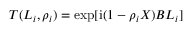<formula> <loc_0><loc_0><loc_500><loc_500>T ( L _ { i } , \rho _ { i } ) = \exp [ i ( 1 - \rho _ { i } X ) B L _ { i } ]</formula> 